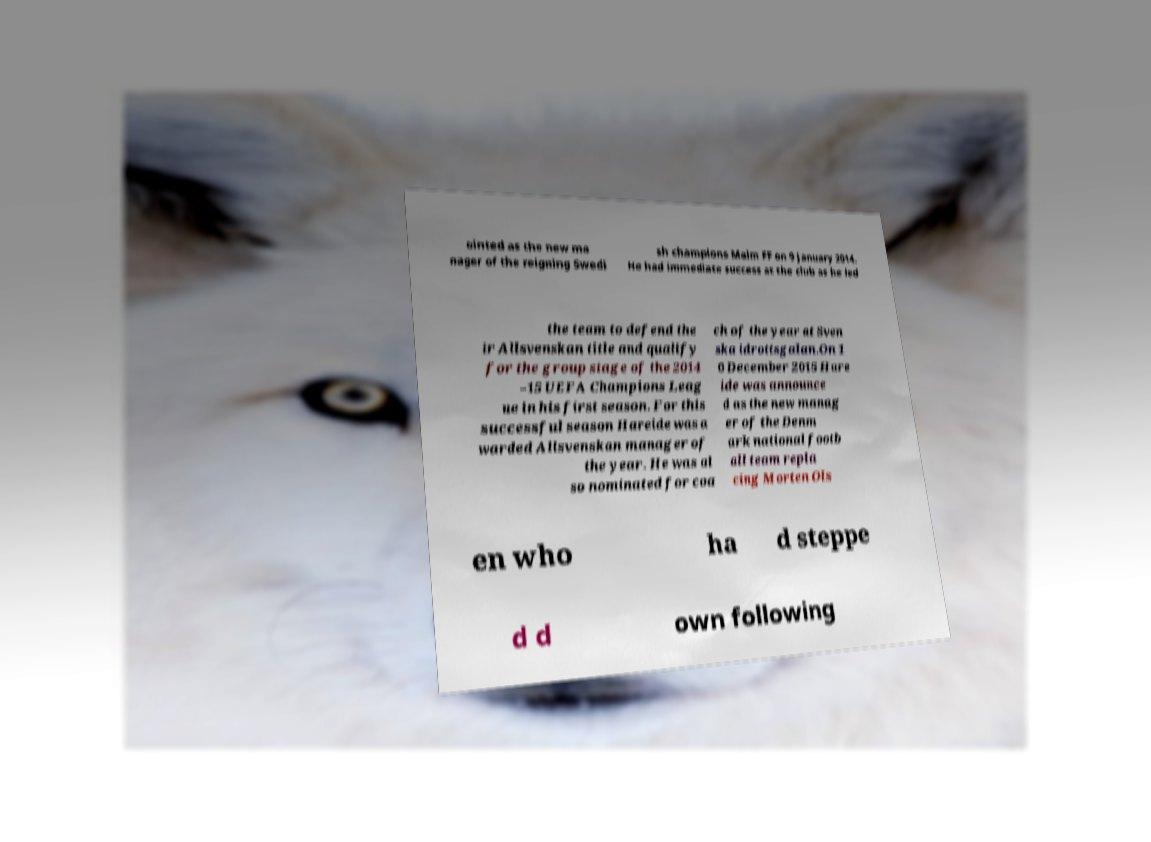There's text embedded in this image that I need extracted. Can you transcribe it verbatim? ointed as the new ma nager of the reigning Swedi sh champions Malm FF on 9 January 2014. He had immediate success at the club as he led the team to defend the ir Allsvenskan title and qualify for the group stage of the 2014 –15 UEFA Champions Leag ue in his first season. For this successful season Hareide was a warded Allsvenskan manager of the year. He was al so nominated for coa ch of the year at Sven ska idrottsgalan.On 1 0 December 2015 Hare ide was announce d as the new manag er of the Denm ark national footb all team repla cing Morten Ols en who ha d steppe d d own following 